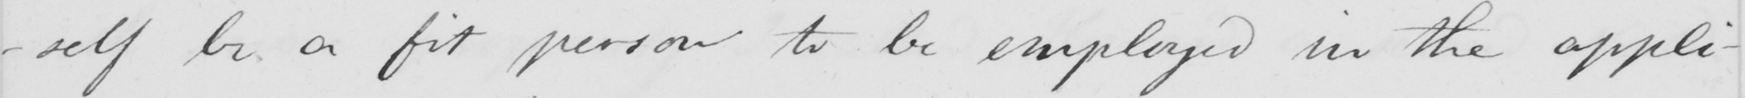What does this handwritten line say? -self be a fit person to be employed in the appli- 